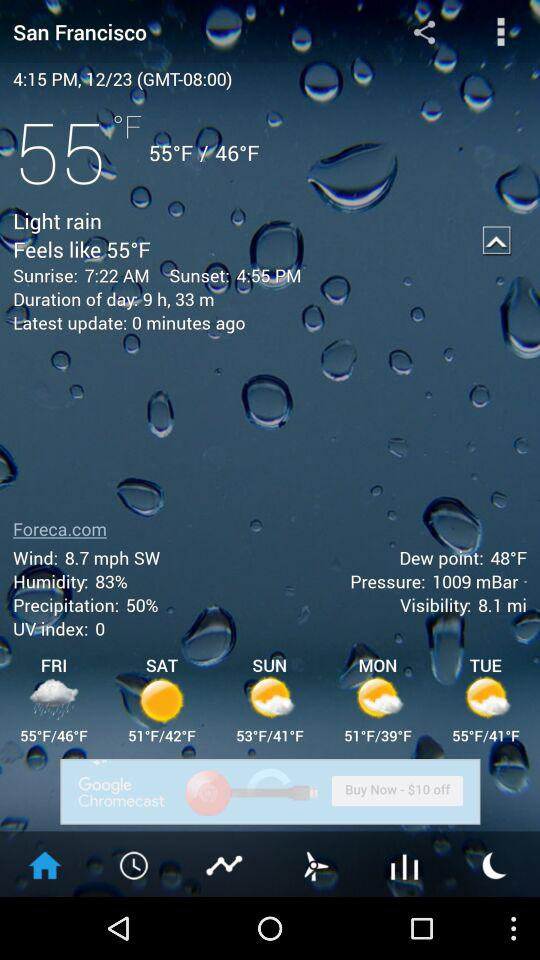What is the sunrise time? The sunrise time is 7:22 AM. 